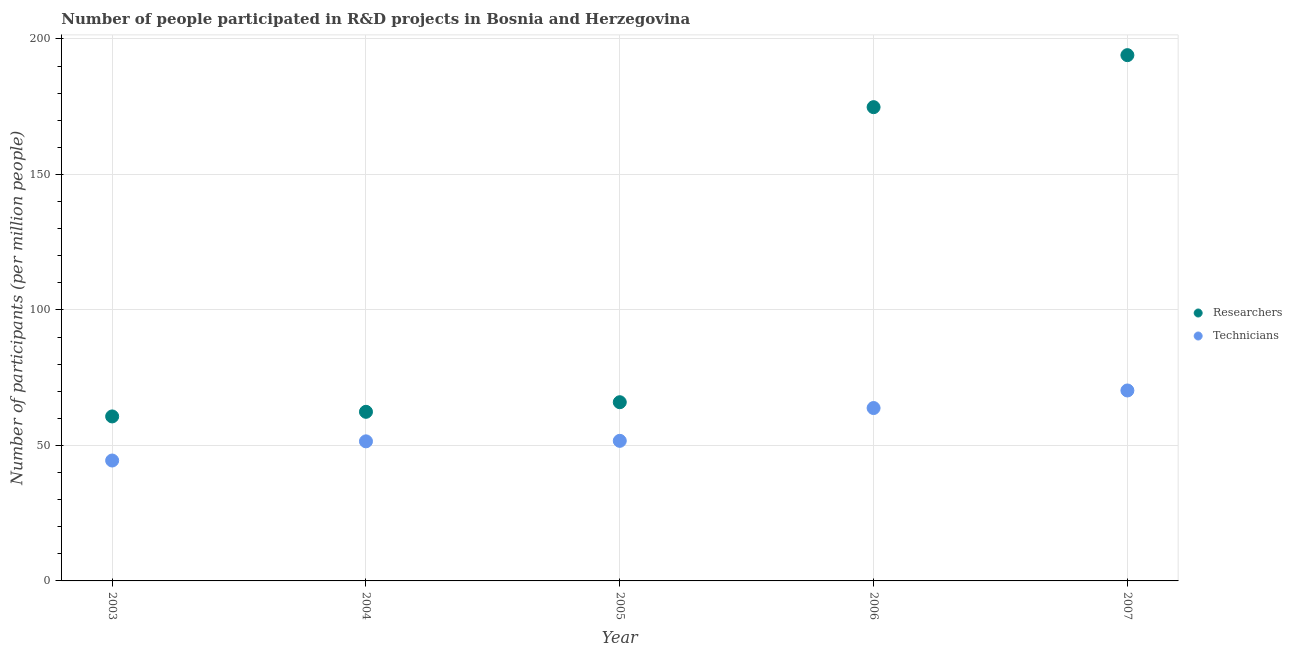How many different coloured dotlines are there?
Your response must be concise. 2. What is the number of researchers in 2004?
Your answer should be compact. 62.41. Across all years, what is the maximum number of researchers?
Keep it short and to the point. 194.03. Across all years, what is the minimum number of researchers?
Ensure brevity in your answer.  60.7. In which year was the number of researchers minimum?
Provide a short and direct response. 2003. What is the total number of technicians in the graph?
Your answer should be very brief. 281.73. What is the difference between the number of researchers in 2004 and that in 2005?
Ensure brevity in your answer.  -3.55. What is the difference between the number of technicians in 2004 and the number of researchers in 2005?
Provide a short and direct response. -14.44. What is the average number of researchers per year?
Your answer should be compact. 111.59. In the year 2006, what is the difference between the number of researchers and number of technicians?
Keep it short and to the point. 111.04. What is the ratio of the number of researchers in 2004 to that in 2006?
Offer a very short reply. 0.36. What is the difference between the highest and the second highest number of researchers?
Ensure brevity in your answer.  19.19. What is the difference between the highest and the lowest number of technicians?
Provide a short and direct response. 25.85. In how many years, is the number of researchers greater than the average number of researchers taken over all years?
Give a very brief answer. 2. Is the number of researchers strictly greater than the number of technicians over the years?
Offer a terse response. Yes. Is the number of technicians strictly less than the number of researchers over the years?
Provide a succinct answer. Yes. What is the difference between two consecutive major ticks on the Y-axis?
Give a very brief answer. 50. Are the values on the major ticks of Y-axis written in scientific E-notation?
Give a very brief answer. No. Does the graph contain any zero values?
Your response must be concise. No. Where does the legend appear in the graph?
Ensure brevity in your answer.  Center right. How many legend labels are there?
Provide a short and direct response. 2. What is the title of the graph?
Make the answer very short. Number of people participated in R&D projects in Bosnia and Herzegovina. What is the label or title of the X-axis?
Your answer should be very brief. Year. What is the label or title of the Y-axis?
Offer a very short reply. Number of participants (per million people). What is the Number of participants (per million people) in Researchers in 2003?
Provide a short and direct response. 60.7. What is the Number of participants (per million people) in Technicians in 2003?
Your answer should be very brief. 44.43. What is the Number of participants (per million people) in Researchers in 2004?
Provide a succinct answer. 62.41. What is the Number of participants (per million people) in Technicians in 2004?
Your answer should be very brief. 51.51. What is the Number of participants (per million people) of Researchers in 2005?
Provide a succinct answer. 65.95. What is the Number of participants (per million people) of Technicians in 2005?
Your answer should be compact. 51.7. What is the Number of participants (per million people) of Researchers in 2006?
Give a very brief answer. 174.84. What is the Number of participants (per million people) of Technicians in 2006?
Your response must be concise. 63.8. What is the Number of participants (per million people) in Researchers in 2007?
Your response must be concise. 194.03. What is the Number of participants (per million people) in Technicians in 2007?
Give a very brief answer. 70.28. Across all years, what is the maximum Number of participants (per million people) in Researchers?
Offer a very short reply. 194.03. Across all years, what is the maximum Number of participants (per million people) in Technicians?
Your answer should be very brief. 70.28. Across all years, what is the minimum Number of participants (per million people) in Researchers?
Offer a very short reply. 60.7. Across all years, what is the minimum Number of participants (per million people) in Technicians?
Your answer should be very brief. 44.43. What is the total Number of participants (per million people) in Researchers in the graph?
Ensure brevity in your answer.  557.93. What is the total Number of participants (per million people) in Technicians in the graph?
Give a very brief answer. 281.73. What is the difference between the Number of participants (per million people) of Researchers in 2003 and that in 2004?
Your answer should be very brief. -1.7. What is the difference between the Number of participants (per million people) of Technicians in 2003 and that in 2004?
Your response must be concise. -7.08. What is the difference between the Number of participants (per million people) in Researchers in 2003 and that in 2005?
Your answer should be very brief. -5.25. What is the difference between the Number of participants (per million people) in Technicians in 2003 and that in 2005?
Offer a very short reply. -7.26. What is the difference between the Number of participants (per million people) in Researchers in 2003 and that in 2006?
Make the answer very short. -114.14. What is the difference between the Number of participants (per million people) in Technicians in 2003 and that in 2006?
Your answer should be compact. -19.37. What is the difference between the Number of participants (per million people) of Researchers in 2003 and that in 2007?
Your answer should be very brief. -133.33. What is the difference between the Number of participants (per million people) in Technicians in 2003 and that in 2007?
Your answer should be compact. -25.85. What is the difference between the Number of participants (per million people) of Researchers in 2004 and that in 2005?
Provide a short and direct response. -3.55. What is the difference between the Number of participants (per million people) of Technicians in 2004 and that in 2005?
Your answer should be compact. -0.19. What is the difference between the Number of participants (per million people) of Researchers in 2004 and that in 2006?
Offer a terse response. -112.43. What is the difference between the Number of participants (per million people) in Technicians in 2004 and that in 2006?
Give a very brief answer. -12.29. What is the difference between the Number of participants (per million people) of Researchers in 2004 and that in 2007?
Ensure brevity in your answer.  -131.63. What is the difference between the Number of participants (per million people) in Technicians in 2004 and that in 2007?
Make the answer very short. -18.77. What is the difference between the Number of participants (per million people) of Researchers in 2005 and that in 2006?
Ensure brevity in your answer.  -108.89. What is the difference between the Number of participants (per million people) of Technicians in 2005 and that in 2006?
Your response must be concise. -12.11. What is the difference between the Number of participants (per million people) of Researchers in 2005 and that in 2007?
Provide a short and direct response. -128.08. What is the difference between the Number of participants (per million people) of Technicians in 2005 and that in 2007?
Provide a short and direct response. -18.59. What is the difference between the Number of participants (per million people) of Researchers in 2006 and that in 2007?
Offer a terse response. -19.19. What is the difference between the Number of participants (per million people) of Technicians in 2006 and that in 2007?
Provide a short and direct response. -6.48. What is the difference between the Number of participants (per million people) of Researchers in 2003 and the Number of participants (per million people) of Technicians in 2004?
Your answer should be compact. 9.19. What is the difference between the Number of participants (per million people) of Researchers in 2003 and the Number of participants (per million people) of Technicians in 2005?
Your answer should be compact. 9.01. What is the difference between the Number of participants (per million people) of Researchers in 2003 and the Number of participants (per million people) of Technicians in 2006?
Ensure brevity in your answer.  -3.1. What is the difference between the Number of participants (per million people) of Researchers in 2003 and the Number of participants (per million people) of Technicians in 2007?
Provide a short and direct response. -9.58. What is the difference between the Number of participants (per million people) in Researchers in 2004 and the Number of participants (per million people) in Technicians in 2005?
Give a very brief answer. 10.71. What is the difference between the Number of participants (per million people) in Researchers in 2004 and the Number of participants (per million people) in Technicians in 2006?
Ensure brevity in your answer.  -1.4. What is the difference between the Number of participants (per million people) of Researchers in 2004 and the Number of participants (per million people) of Technicians in 2007?
Offer a very short reply. -7.88. What is the difference between the Number of participants (per million people) of Researchers in 2005 and the Number of participants (per million people) of Technicians in 2006?
Offer a very short reply. 2.15. What is the difference between the Number of participants (per million people) in Researchers in 2005 and the Number of participants (per million people) in Technicians in 2007?
Give a very brief answer. -4.33. What is the difference between the Number of participants (per million people) in Researchers in 2006 and the Number of participants (per million people) in Technicians in 2007?
Ensure brevity in your answer.  104.56. What is the average Number of participants (per million people) in Researchers per year?
Provide a succinct answer. 111.59. What is the average Number of participants (per million people) in Technicians per year?
Make the answer very short. 56.35. In the year 2003, what is the difference between the Number of participants (per million people) of Researchers and Number of participants (per million people) of Technicians?
Your answer should be compact. 16.27. In the year 2004, what is the difference between the Number of participants (per million people) of Researchers and Number of participants (per million people) of Technicians?
Offer a very short reply. 10.89. In the year 2005, what is the difference between the Number of participants (per million people) of Researchers and Number of participants (per million people) of Technicians?
Offer a very short reply. 14.25. In the year 2006, what is the difference between the Number of participants (per million people) in Researchers and Number of participants (per million people) in Technicians?
Provide a short and direct response. 111.04. In the year 2007, what is the difference between the Number of participants (per million people) in Researchers and Number of participants (per million people) in Technicians?
Keep it short and to the point. 123.75. What is the ratio of the Number of participants (per million people) of Researchers in 2003 to that in 2004?
Ensure brevity in your answer.  0.97. What is the ratio of the Number of participants (per million people) in Technicians in 2003 to that in 2004?
Your answer should be compact. 0.86. What is the ratio of the Number of participants (per million people) in Researchers in 2003 to that in 2005?
Your answer should be very brief. 0.92. What is the ratio of the Number of participants (per million people) in Technicians in 2003 to that in 2005?
Provide a short and direct response. 0.86. What is the ratio of the Number of participants (per million people) of Researchers in 2003 to that in 2006?
Ensure brevity in your answer.  0.35. What is the ratio of the Number of participants (per million people) of Technicians in 2003 to that in 2006?
Keep it short and to the point. 0.7. What is the ratio of the Number of participants (per million people) of Researchers in 2003 to that in 2007?
Provide a short and direct response. 0.31. What is the ratio of the Number of participants (per million people) in Technicians in 2003 to that in 2007?
Your answer should be compact. 0.63. What is the ratio of the Number of participants (per million people) in Researchers in 2004 to that in 2005?
Keep it short and to the point. 0.95. What is the ratio of the Number of participants (per million people) in Researchers in 2004 to that in 2006?
Your answer should be compact. 0.36. What is the ratio of the Number of participants (per million people) in Technicians in 2004 to that in 2006?
Ensure brevity in your answer.  0.81. What is the ratio of the Number of participants (per million people) in Researchers in 2004 to that in 2007?
Ensure brevity in your answer.  0.32. What is the ratio of the Number of participants (per million people) in Technicians in 2004 to that in 2007?
Provide a succinct answer. 0.73. What is the ratio of the Number of participants (per million people) in Researchers in 2005 to that in 2006?
Make the answer very short. 0.38. What is the ratio of the Number of participants (per million people) of Technicians in 2005 to that in 2006?
Offer a terse response. 0.81. What is the ratio of the Number of participants (per million people) in Researchers in 2005 to that in 2007?
Make the answer very short. 0.34. What is the ratio of the Number of participants (per million people) of Technicians in 2005 to that in 2007?
Provide a succinct answer. 0.74. What is the ratio of the Number of participants (per million people) in Researchers in 2006 to that in 2007?
Ensure brevity in your answer.  0.9. What is the ratio of the Number of participants (per million people) in Technicians in 2006 to that in 2007?
Your answer should be compact. 0.91. What is the difference between the highest and the second highest Number of participants (per million people) in Researchers?
Give a very brief answer. 19.19. What is the difference between the highest and the second highest Number of participants (per million people) of Technicians?
Make the answer very short. 6.48. What is the difference between the highest and the lowest Number of participants (per million people) of Researchers?
Your answer should be very brief. 133.33. What is the difference between the highest and the lowest Number of participants (per million people) of Technicians?
Provide a succinct answer. 25.85. 